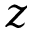<formula> <loc_0><loc_0><loc_500><loc_500>z</formula> 